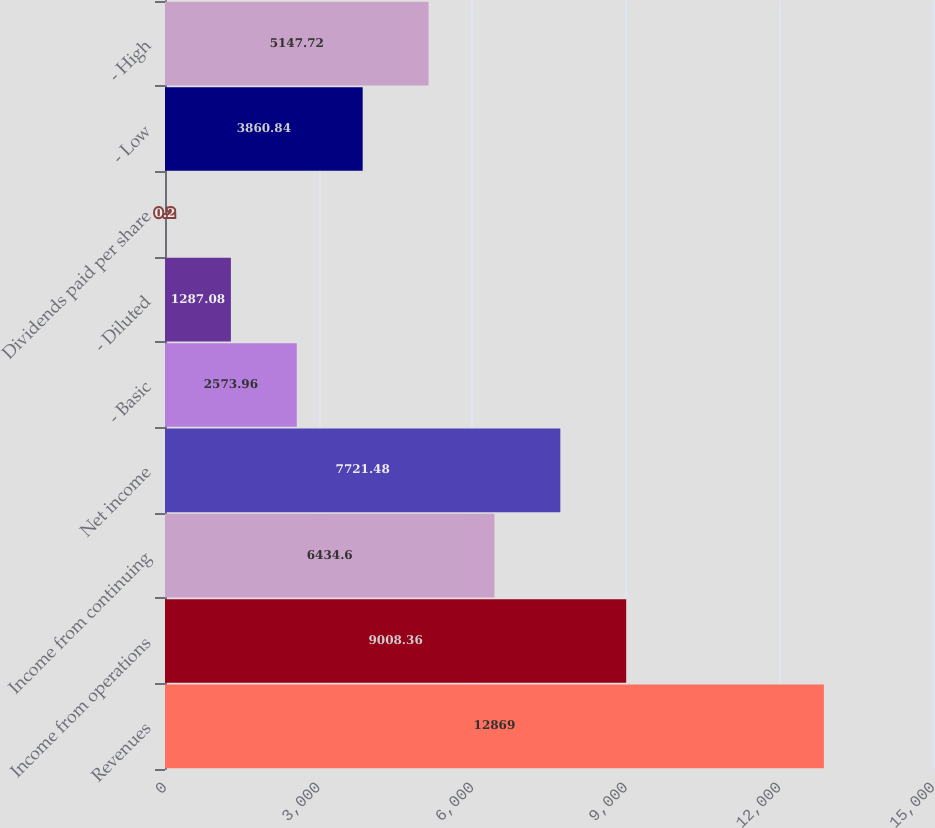Convert chart. <chart><loc_0><loc_0><loc_500><loc_500><bar_chart><fcel>Revenues<fcel>Income from operations<fcel>Income from continuing<fcel>Net income<fcel>- Basic<fcel>- Diluted<fcel>Dividends paid per share<fcel>- Low<fcel>- High<nl><fcel>12869<fcel>9008.36<fcel>6434.6<fcel>7721.48<fcel>2573.96<fcel>1287.08<fcel>0.2<fcel>3860.84<fcel>5147.72<nl></chart> 